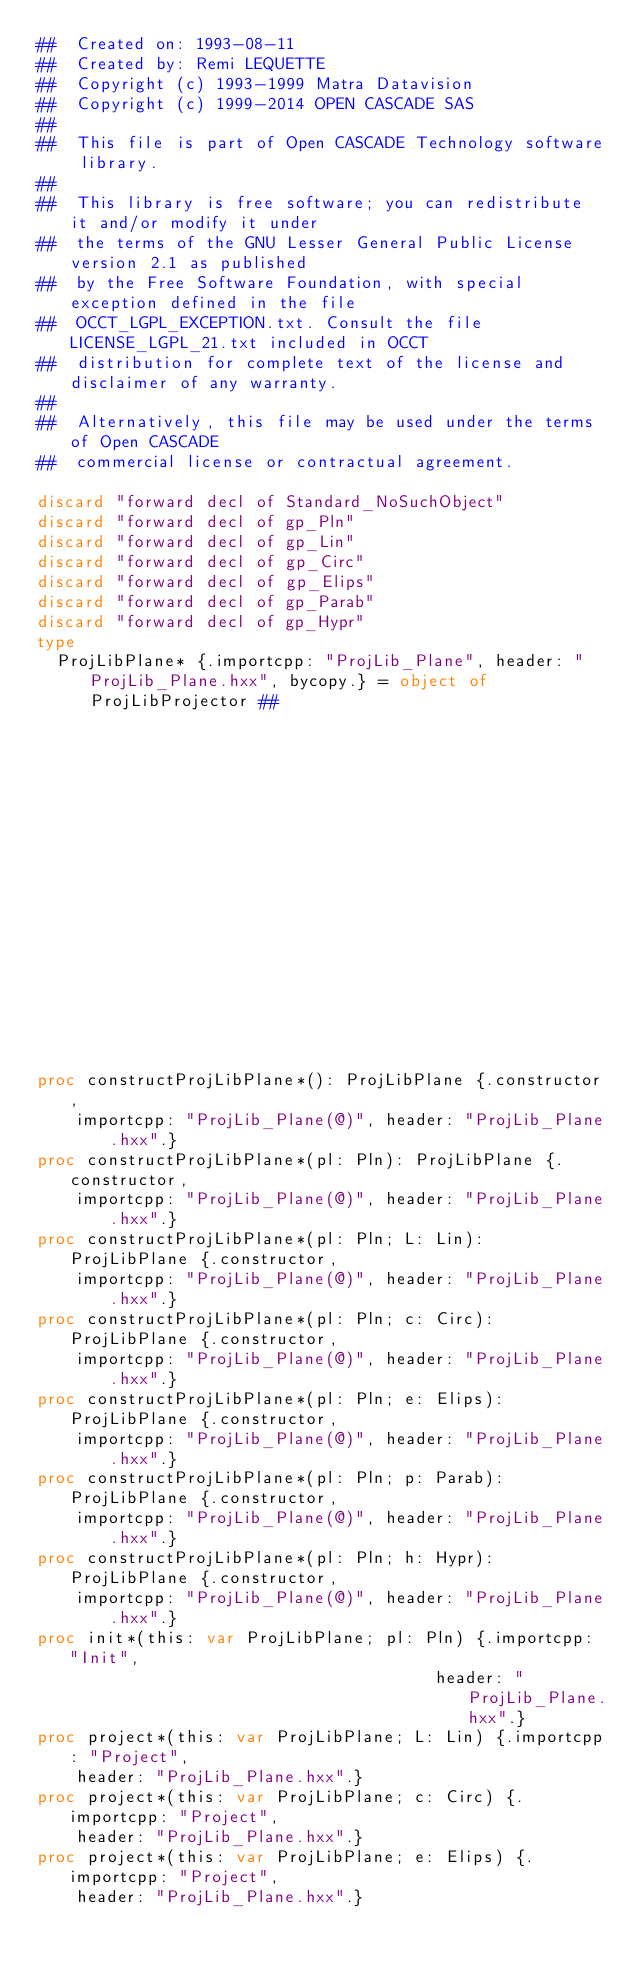Convert code to text. <code><loc_0><loc_0><loc_500><loc_500><_Nim_>##  Created on: 1993-08-11
##  Created by: Remi LEQUETTE
##  Copyright (c) 1993-1999 Matra Datavision
##  Copyright (c) 1999-2014 OPEN CASCADE SAS
##
##  This file is part of Open CASCADE Technology software library.
##
##  This library is free software; you can redistribute it and/or modify it under
##  the terms of the GNU Lesser General Public License version 2.1 as published
##  by the Free Software Foundation, with special exception defined in the file
##  OCCT_LGPL_EXCEPTION.txt. Consult the file LICENSE_LGPL_21.txt included in OCCT
##  distribution for complete text of the license and disclaimer of any warranty.
##
##  Alternatively, this file may be used under the terms of Open CASCADE
##  commercial license or contractual agreement.

discard "forward decl of Standard_NoSuchObject"
discard "forward decl of gp_Pln"
discard "forward decl of gp_Lin"
discard "forward decl of gp_Circ"
discard "forward decl of gp_Elips"
discard "forward decl of gp_Parab"
discard "forward decl of gp_Hypr"
type
  ProjLibPlane* {.importcpp: "ProjLib_Plane", header: "ProjLib_Plane.hxx", bycopy.} = object of ProjLibProjector ##
                                                                                                       ## !
                                                                                                       ## Undefined
                                                                                                       ## projection.


proc constructProjLibPlane*(): ProjLibPlane {.constructor,
    importcpp: "ProjLib_Plane(@)", header: "ProjLib_Plane.hxx".}
proc constructProjLibPlane*(pl: Pln): ProjLibPlane {.constructor,
    importcpp: "ProjLib_Plane(@)", header: "ProjLib_Plane.hxx".}
proc constructProjLibPlane*(pl: Pln; L: Lin): ProjLibPlane {.constructor,
    importcpp: "ProjLib_Plane(@)", header: "ProjLib_Plane.hxx".}
proc constructProjLibPlane*(pl: Pln; c: Circ): ProjLibPlane {.constructor,
    importcpp: "ProjLib_Plane(@)", header: "ProjLib_Plane.hxx".}
proc constructProjLibPlane*(pl: Pln; e: Elips): ProjLibPlane {.constructor,
    importcpp: "ProjLib_Plane(@)", header: "ProjLib_Plane.hxx".}
proc constructProjLibPlane*(pl: Pln; p: Parab): ProjLibPlane {.constructor,
    importcpp: "ProjLib_Plane(@)", header: "ProjLib_Plane.hxx".}
proc constructProjLibPlane*(pl: Pln; h: Hypr): ProjLibPlane {.constructor,
    importcpp: "ProjLib_Plane(@)", header: "ProjLib_Plane.hxx".}
proc init*(this: var ProjLibPlane; pl: Pln) {.importcpp: "Init",
                                        header: "ProjLib_Plane.hxx".}
proc project*(this: var ProjLibPlane; L: Lin) {.importcpp: "Project",
    header: "ProjLib_Plane.hxx".}
proc project*(this: var ProjLibPlane; c: Circ) {.importcpp: "Project",
    header: "ProjLib_Plane.hxx".}
proc project*(this: var ProjLibPlane; e: Elips) {.importcpp: "Project",
    header: "ProjLib_Plane.hxx".}</code> 